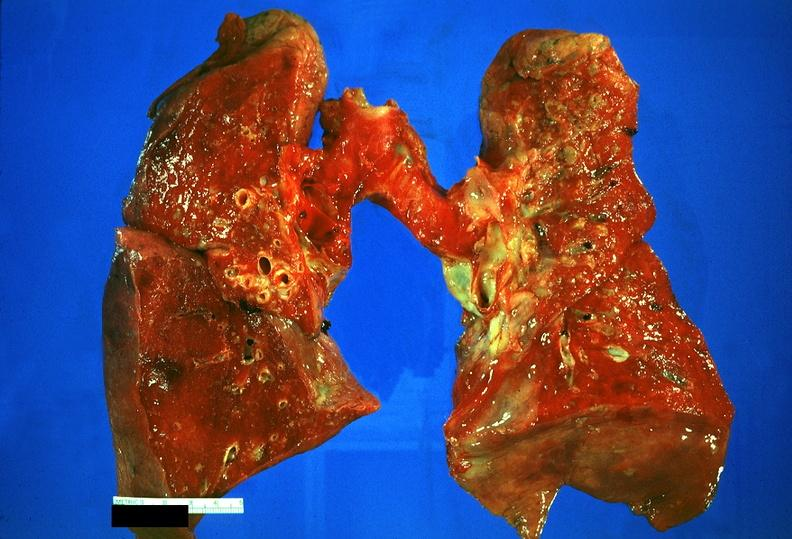s respiratory present?
Answer the question using a single word or phrase. Yes 